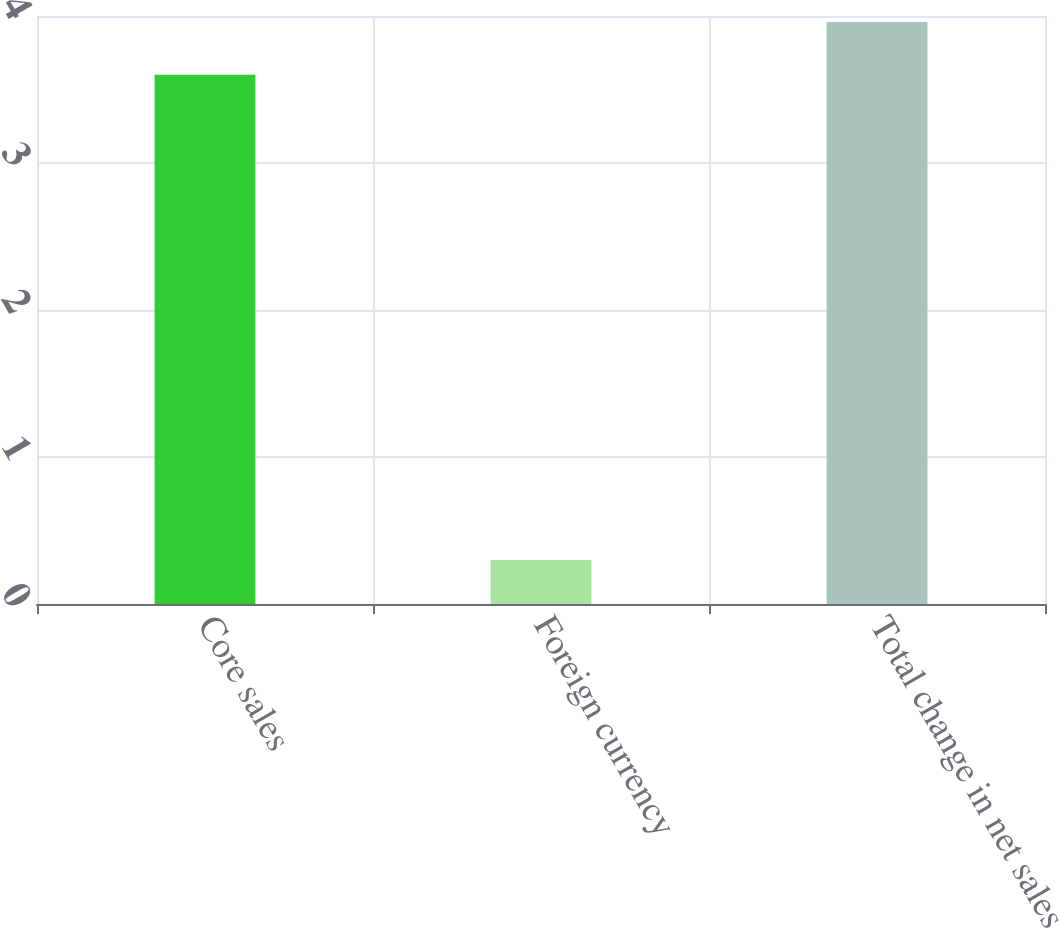<chart> <loc_0><loc_0><loc_500><loc_500><bar_chart><fcel>Core sales<fcel>Foreign currency<fcel>Total change in net sales<nl><fcel>3.6<fcel>0.3<fcel>3.96<nl></chart> 